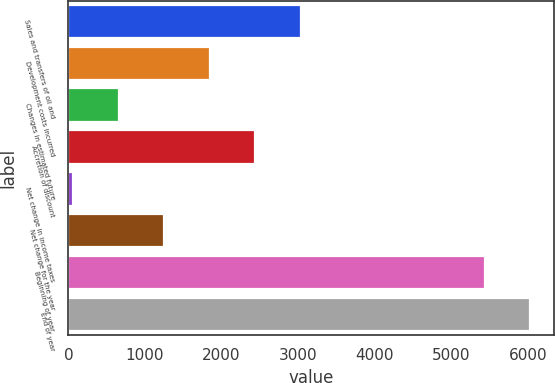Convert chart. <chart><loc_0><loc_0><loc_500><loc_500><bar_chart><fcel>Sales and transfers of oil and<fcel>Development costs incurred<fcel>Changes in estimated future<fcel>Accretion of discount<fcel>Net change in income taxes<fcel>Net change for the year<fcel>Beginning of year<fcel>End of year<nl><fcel>3033<fcel>1845.8<fcel>658.6<fcel>2439.4<fcel>65<fcel>1252.2<fcel>5441<fcel>6034.6<nl></chart> 